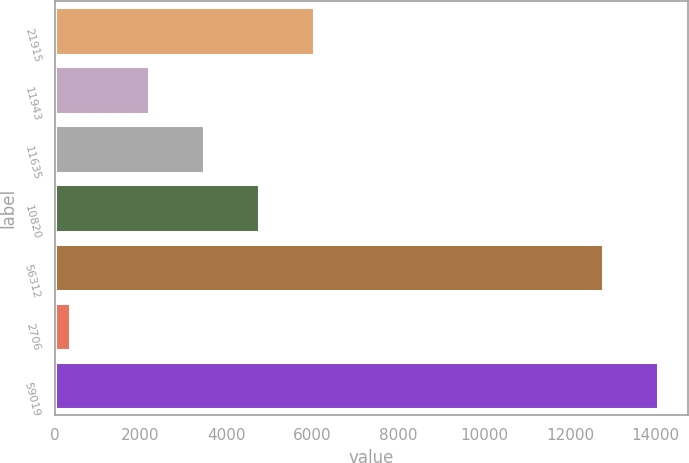Convert chart to OTSL. <chart><loc_0><loc_0><loc_500><loc_500><bar_chart><fcel>21915<fcel>11943<fcel>11635<fcel>10820<fcel>56312<fcel>2706<fcel>59019<nl><fcel>6036.18<fcel>2204.7<fcel>3481.86<fcel>4759.02<fcel>12771.6<fcel>347.5<fcel>14048.8<nl></chart> 